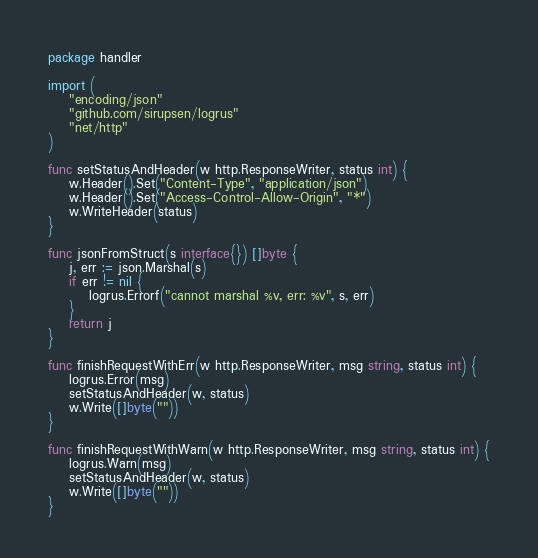Convert code to text. <code><loc_0><loc_0><loc_500><loc_500><_Go_>package handler

import (
	"encoding/json"
	"github.com/sirupsen/logrus"
	"net/http"
)

func setStatusAndHeader(w http.ResponseWriter, status int) {
	w.Header().Set("Content-Type", "application/json")
	w.Header().Set("Access-Control-Allow-Origin", "*")
	w.WriteHeader(status)
}

func jsonFromStruct(s interface{}) []byte {
	j, err := json.Marshal(s)
	if err != nil {
		logrus.Errorf("cannot marshal %v, err: %v", s, err)
	}
	return j
}

func finishRequestWithErr(w http.ResponseWriter, msg string, status int) {
	logrus.Error(msg)
	setStatusAndHeader(w, status)
	w.Write([]byte(""))
}

func finishRequestWithWarn(w http.ResponseWriter, msg string, status int) {
	logrus.Warn(msg)
	setStatusAndHeader(w, status)
	w.Write([]byte(""))
}
</code> 